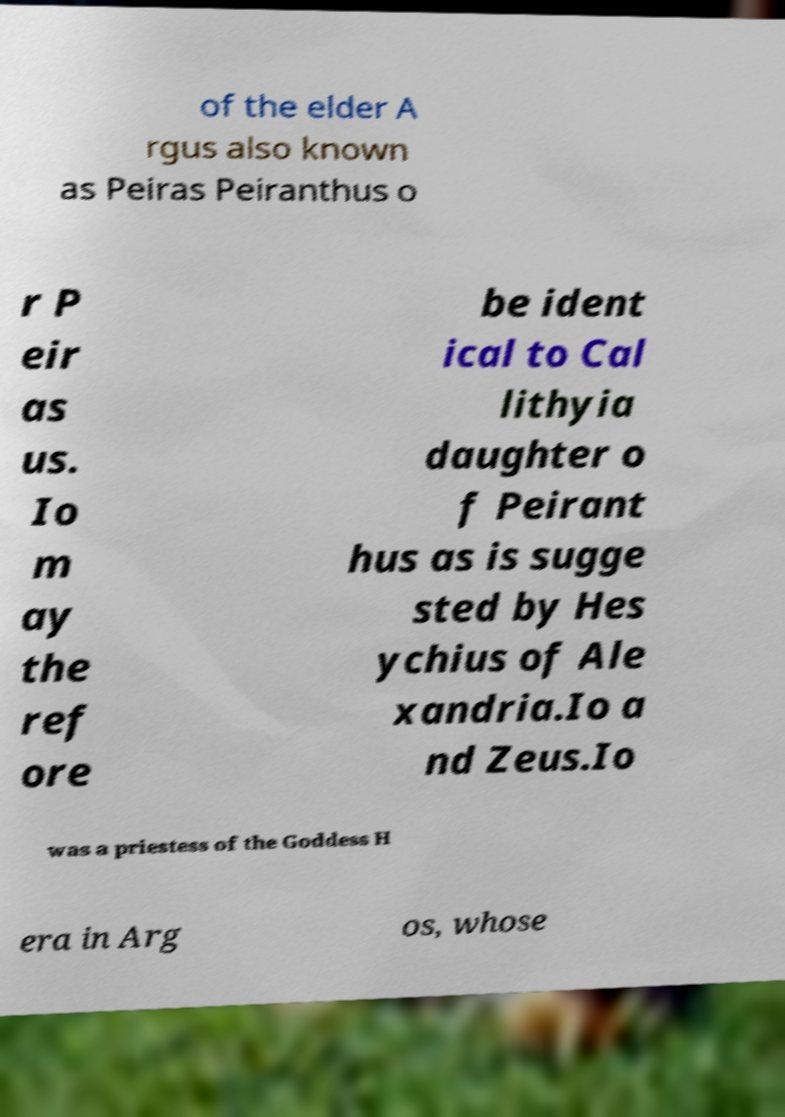What messages or text are displayed in this image? I need them in a readable, typed format. of the elder A rgus also known as Peiras Peiranthus o r P eir as us. Io m ay the ref ore be ident ical to Cal lithyia daughter o f Peirant hus as is sugge sted by Hes ychius of Ale xandria.Io a nd Zeus.Io was a priestess of the Goddess H era in Arg os, whose 